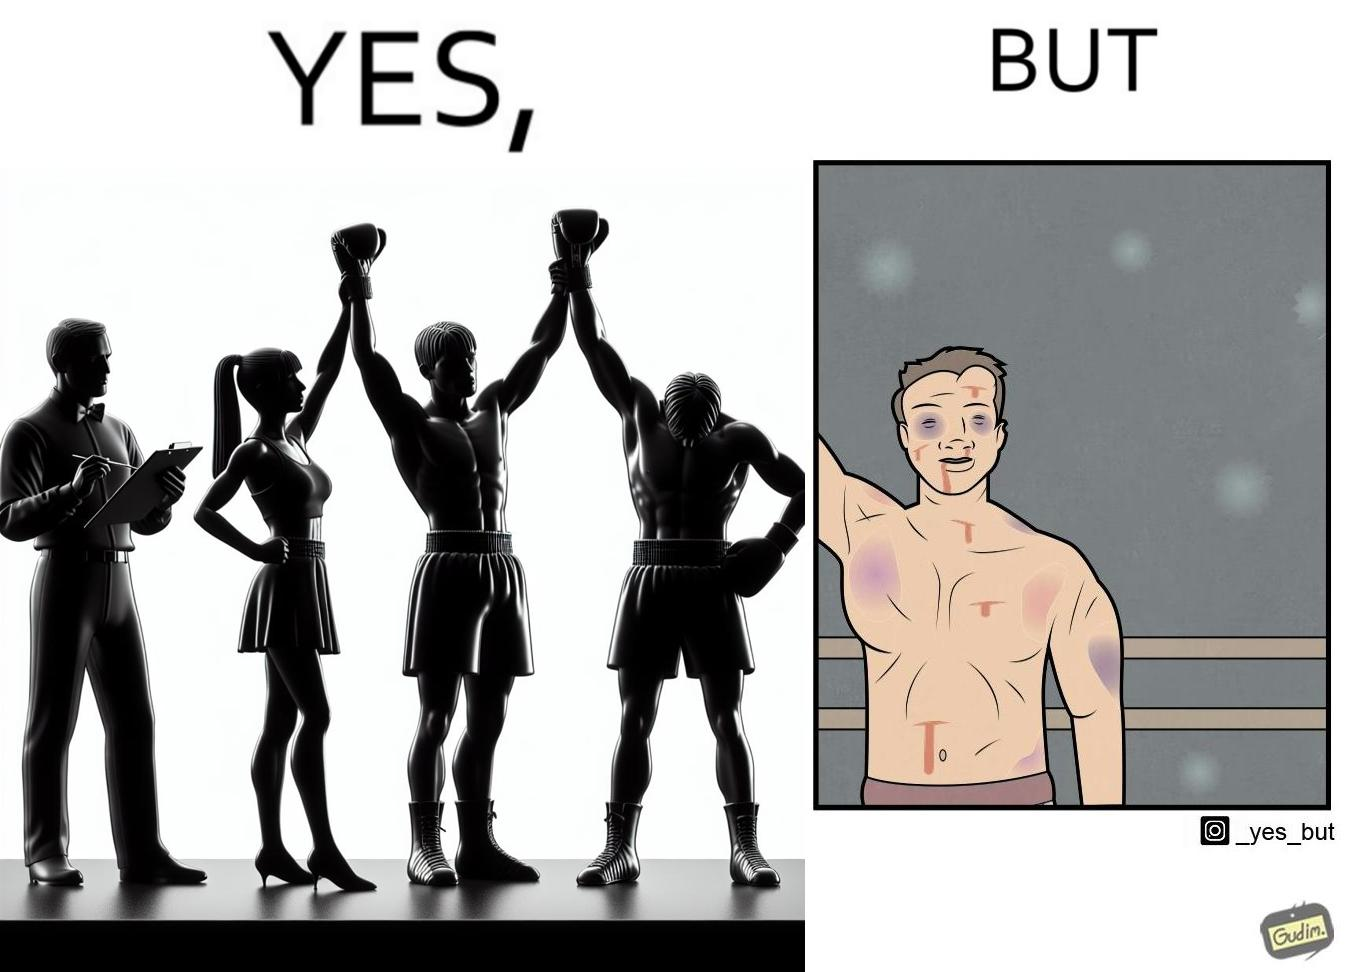What is the satirical meaning behind this image? The image is ironic because even though a boxer has won the match and it is supposed to be a moment of celebration, the boxer got bruised in several places during the match. This is an illustration of what hurdles a person has to go through in order to succeed. 